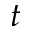Convert formula to latex. <formula><loc_0><loc_0><loc_500><loc_500>t</formula> 